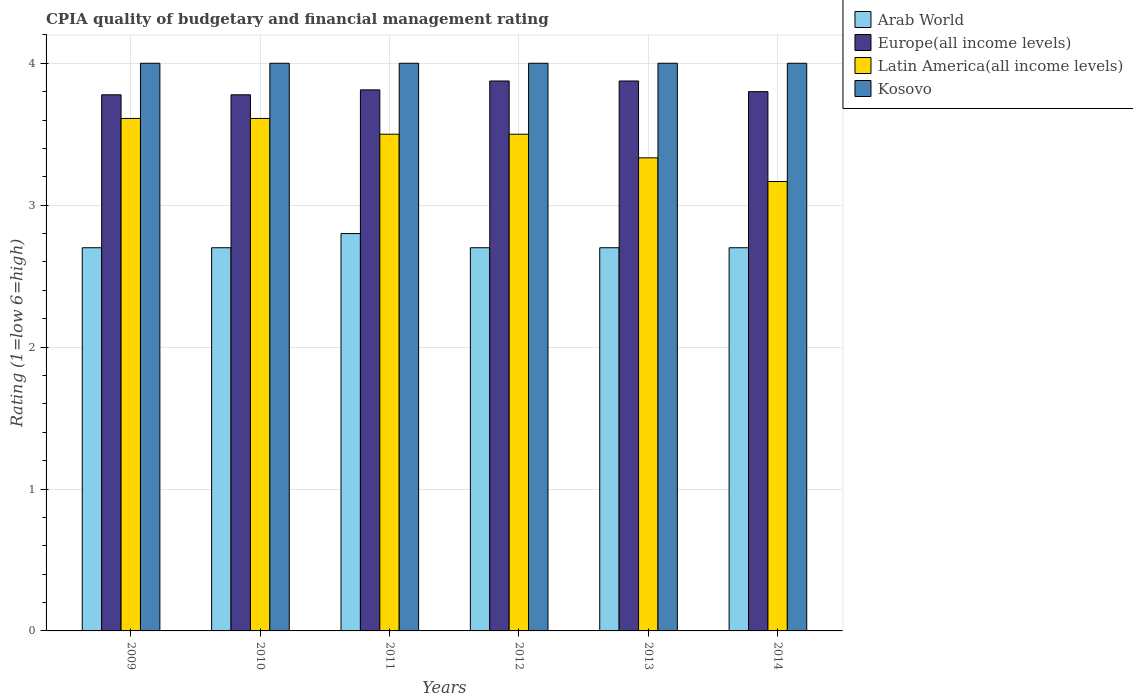Are the number of bars on each tick of the X-axis equal?
Make the answer very short. Yes. How many bars are there on the 1st tick from the left?
Make the answer very short. 4. What is the label of the 4th group of bars from the left?
Your response must be concise. 2012. In how many cases, is the number of bars for a given year not equal to the number of legend labels?
Your answer should be compact. 0. What is the CPIA rating in Europe(all income levels) in 2010?
Make the answer very short. 3.78. Across all years, what is the maximum CPIA rating in Latin America(all income levels)?
Your response must be concise. 3.61. Across all years, what is the minimum CPIA rating in Latin America(all income levels)?
Ensure brevity in your answer.  3.17. In which year was the CPIA rating in Kosovo maximum?
Offer a very short reply. 2009. What is the total CPIA rating in Latin America(all income levels) in the graph?
Give a very brief answer. 20.72. What is the difference between the CPIA rating in Latin America(all income levels) in 2009 and that in 2013?
Provide a short and direct response. 0.28. What is the difference between the CPIA rating in Latin America(all income levels) in 2014 and the CPIA rating in Europe(all income levels) in 2012?
Offer a very short reply. -0.71. What is the average CPIA rating in Latin America(all income levels) per year?
Offer a very short reply. 3.45. In the year 2013, what is the difference between the CPIA rating in Kosovo and CPIA rating in Arab World?
Offer a terse response. 1.3. In how many years, is the CPIA rating in Kosovo greater than 2.8?
Provide a succinct answer. 6. What is the ratio of the CPIA rating in Europe(all income levels) in 2009 to that in 2013?
Ensure brevity in your answer.  0.97. Is the CPIA rating in Latin America(all income levels) in 2010 less than that in 2012?
Provide a succinct answer. No. What is the difference between the highest and the second highest CPIA rating in Arab World?
Provide a short and direct response. 0.1. What is the difference between the highest and the lowest CPIA rating in Latin America(all income levels)?
Give a very brief answer. 0.44. Is it the case that in every year, the sum of the CPIA rating in Arab World and CPIA rating in Kosovo is greater than the sum of CPIA rating in Europe(all income levels) and CPIA rating in Latin America(all income levels)?
Make the answer very short. Yes. What does the 3rd bar from the left in 2012 represents?
Your answer should be very brief. Latin America(all income levels). What does the 4th bar from the right in 2012 represents?
Offer a terse response. Arab World. Is it the case that in every year, the sum of the CPIA rating in Europe(all income levels) and CPIA rating in Latin America(all income levels) is greater than the CPIA rating in Arab World?
Make the answer very short. Yes. How many bars are there?
Give a very brief answer. 24. Are all the bars in the graph horizontal?
Offer a very short reply. No. What is the difference between two consecutive major ticks on the Y-axis?
Offer a terse response. 1. Where does the legend appear in the graph?
Offer a very short reply. Top right. What is the title of the graph?
Ensure brevity in your answer.  CPIA quality of budgetary and financial management rating. Does "Finland" appear as one of the legend labels in the graph?
Provide a succinct answer. No. What is the label or title of the X-axis?
Give a very brief answer. Years. What is the label or title of the Y-axis?
Your answer should be compact. Rating (1=low 6=high). What is the Rating (1=low 6=high) in Arab World in 2009?
Provide a succinct answer. 2.7. What is the Rating (1=low 6=high) of Europe(all income levels) in 2009?
Keep it short and to the point. 3.78. What is the Rating (1=low 6=high) of Latin America(all income levels) in 2009?
Provide a short and direct response. 3.61. What is the Rating (1=low 6=high) of Europe(all income levels) in 2010?
Provide a short and direct response. 3.78. What is the Rating (1=low 6=high) in Latin America(all income levels) in 2010?
Ensure brevity in your answer.  3.61. What is the Rating (1=low 6=high) in Europe(all income levels) in 2011?
Provide a short and direct response. 3.81. What is the Rating (1=low 6=high) of Arab World in 2012?
Your response must be concise. 2.7. What is the Rating (1=low 6=high) in Europe(all income levels) in 2012?
Make the answer very short. 3.88. What is the Rating (1=low 6=high) in Latin America(all income levels) in 2012?
Your answer should be very brief. 3.5. What is the Rating (1=low 6=high) in Kosovo in 2012?
Offer a very short reply. 4. What is the Rating (1=low 6=high) in Europe(all income levels) in 2013?
Your answer should be compact. 3.88. What is the Rating (1=low 6=high) of Latin America(all income levels) in 2013?
Your response must be concise. 3.33. What is the Rating (1=low 6=high) in Kosovo in 2013?
Offer a very short reply. 4. What is the Rating (1=low 6=high) of Latin America(all income levels) in 2014?
Your answer should be very brief. 3.17. What is the Rating (1=low 6=high) in Kosovo in 2014?
Your answer should be very brief. 4. Across all years, what is the maximum Rating (1=low 6=high) in Europe(all income levels)?
Offer a terse response. 3.88. Across all years, what is the maximum Rating (1=low 6=high) in Latin America(all income levels)?
Provide a short and direct response. 3.61. Across all years, what is the minimum Rating (1=low 6=high) of Europe(all income levels)?
Offer a very short reply. 3.78. Across all years, what is the minimum Rating (1=low 6=high) in Latin America(all income levels)?
Give a very brief answer. 3.17. What is the total Rating (1=low 6=high) in Europe(all income levels) in the graph?
Give a very brief answer. 22.92. What is the total Rating (1=low 6=high) of Latin America(all income levels) in the graph?
Give a very brief answer. 20.72. What is the total Rating (1=low 6=high) of Kosovo in the graph?
Provide a short and direct response. 24. What is the difference between the Rating (1=low 6=high) of Kosovo in 2009 and that in 2010?
Offer a terse response. 0. What is the difference between the Rating (1=low 6=high) of Europe(all income levels) in 2009 and that in 2011?
Your answer should be very brief. -0.03. What is the difference between the Rating (1=low 6=high) of Europe(all income levels) in 2009 and that in 2012?
Offer a terse response. -0.1. What is the difference between the Rating (1=low 6=high) in Kosovo in 2009 and that in 2012?
Your answer should be very brief. 0. What is the difference between the Rating (1=low 6=high) of Arab World in 2009 and that in 2013?
Provide a succinct answer. 0. What is the difference between the Rating (1=low 6=high) in Europe(all income levels) in 2009 and that in 2013?
Offer a very short reply. -0.1. What is the difference between the Rating (1=low 6=high) of Latin America(all income levels) in 2009 and that in 2013?
Ensure brevity in your answer.  0.28. What is the difference between the Rating (1=low 6=high) in Arab World in 2009 and that in 2014?
Your answer should be compact. 0. What is the difference between the Rating (1=low 6=high) in Europe(all income levels) in 2009 and that in 2014?
Offer a terse response. -0.02. What is the difference between the Rating (1=low 6=high) in Latin America(all income levels) in 2009 and that in 2014?
Make the answer very short. 0.44. What is the difference between the Rating (1=low 6=high) in Arab World in 2010 and that in 2011?
Offer a very short reply. -0.1. What is the difference between the Rating (1=low 6=high) of Europe(all income levels) in 2010 and that in 2011?
Your response must be concise. -0.03. What is the difference between the Rating (1=low 6=high) in Latin America(all income levels) in 2010 and that in 2011?
Offer a very short reply. 0.11. What is the difference between the Rating (1=low 6=high) in Arab World in 2010 and that in 2012?
Your response must be concise. 0. What is the difference between the Rating (1=low 6=high) of Europe(all income levels) in 2010 and that in 2012?
Make the answer very short. -0.1. What is the difference between the Rating (1=low 6=high) in Latin America(all income levels) in 2010 and that in 2012?
Your answer should be very brief. 0.11. What is the difference between the Rating (1=low 6=high) of Europe(all income levels) in 2010 and that in 2013?
Your response must be concise. -0.1. What is the difference between the Rating (1=low 6=high) in Latin America(all income levels) in 2010 and that in 2013?
Your answer should be very brief. 0.28. What is the difference between the Rating (1=low 6=high) of Kosovo in 2010 and that in 2013?
Provide a succinct answer. 0. What is the difference between the Rating (1=low 6=high) of Arab World in 2010 and that in 2014?
Provide a short and direct response. 0. What is the difference between the Rating (1=low 6=high) in Europe(all income levels) in 2010 and that in 2014?
Provide a succinct answer. -0.02. What is the difference between the Rating (1=low 6=high) of Latin America(all income levels) in 2010 and that in 2014?
Offer a very short reply. 0.44. What is the difference between the Rating (1=low 6=high) in Arab World in 2011 and that in 2012?
Your answer should be compact. 0.1. What is the difference between the Rating (1=low 6=high) in Europe(all income levels) in 2011 and that in 2012?
Your response must be concise. -0.06. What is the difference between the Rating (1=low 6=high) in Latin America(all income levels) in 2011 and that in 2012?
Provide a short and direct response. 0. What is the difference between the Rating (1=low 6=high) of Arab World in 2011 and that in 2013?
Your response must be concise. 0.1. What is the difference between the Rating (1=low 6=high) of Europe(all income levels) in 2011 and that in 2013?
Offer a very short reply. -0.06. What is the difference between the Rating (1=low 6=high) in Kosovo in 2011 and that in 2013?
Ensure brevity in your answer.  0. What is the difference between the Rating (1=low 6=high) in Europe(all income levels) in 2011 and that in 2014?
Your response must be concise. 0.01. What is the difference between the Rating (1=low 6=high) in Arab World in 2012 and that in 2013?
Offer a terse response. 0. What is the difference between the Rating (1=low 6=high) of Europe(all income levels) in 2012 and that in 2013?
Your answer should be very brief. 0. What is the difference between the Rating (1=low 6=high) of Latin America(all income levels) in 2012 and that in 2013?
Your answer should be compact. 0.17. What is the difference between the Rating (1=low 6=high) in Kosovo in 2012 and that in 2013?
Ensure brevity in your answer.  0. What is the difference between the Rating (1=low 6=high) in Europe(all income levels) in 2012 and that in 2014?
Your answer should be very brief. 0.07. What is the difference between the Rating (1=low 6=high) of Europe(all income levels) in 2013 and that in 2014?
Your answer should be compact. 0.07. What is the difference between the Rating (1=low 6=high) of Latin America(all income levels) in 2013 and that in 2014?
Offer a very short reply. 0.17. What is the difference between the Rating (1=low 6=high) of Arab World in 2009 and the Rating (1=low 6=high) of Europe(all income levels) in 2010?
Offer a very short reply. -1.08. What is the difference between the Rating (1=low 6=high) in Arab World in 2009 and the Rating (1=low 6=high) in Latin America(all income levels) in 2010?
Give a very brief answer. -0.91. What is the difference between the Rating (1=low 6=high) of Arab World in 2009 and the Rating (1=low 6=high) of Kosovo in 2010?
Provide a succinct answer. -1.3. What is the difference between the Rating (1=low 6=high) of Europe(all income levels) in 2009 and the Rating (1=low 6=high) of Kosovo in 2010?
Offer a terse response. -0.22. What is the difference between the Rating (1=low 6=high) of Latin America(all income levels) in 2009 and the Rating (1=low 6=high) of Kosovo in 2010?
Offer a terse response. -0.39. What is the difference between the Rating (1=low 6=high) in Arab World in 2009 and the Rating (1=low 6=high) in Europe(all income levels) in 2011?
Provide a succinct answer. -1.11. What is the difference between the Rating (1=low 6=high) of Arab World in 2009 and the Rating (1=low 6=high) of Latin America(all income levels) in 2011?
Keep it short and to the point. -0.8. What is the difference between the Rating (1=low 6=high) in Arab World in 2009 and the Rating (1=low 6=high) in Kosovo in 2011?
Your response must be concise. -1.3. What is the difference between the Rating (1=low 6=high) of Europe(all income levels) in 2009 and the Rating (1=low 6=high) of Latin America(all income levels) in 2011?
Offer a terse response. 0.28. What is the difference between the Rating (1=low 6=high) in Europe(all income levels) in 2009 and the Rating (1=low 6=high) in Kosovo in 2011?
Provide a succinct answer. -0.22. What is the difference between the Rating (1=low 6=high) in Latin America(all income levels) in 2009 and the Rating (1=low 6=high) in Kosovo in 2011?
Your answer should be compact. -0.39. What is the difference between the Rating (1=low 6=high) in Arab World in 2009 and the Rating (1=low 6=high) in Europe(all income levels) in 2012?
Offer a very short reply. -1.18. What is the difference between the Rating (1=low 6=high) of Arab World in 2009 and the Rating (1=low 6=high) of Latin America(all income levels) in 2012?
Your response must be concise. -0.8. What is the difference between the Rating (1=low 6=high) of Arab World in 2009 and the Rating (1=low 6=high) of Kosovo in 2012?
Make the answer very short. -1.3. What is the difference between the Rating (1=low 6=high) in Europe(all income levels) in 2009 and the Rating (1=low 6=high) in Latin America(all income levels) in 2012?
Your answer should be compact. 0.28. What is the difference between the Rating (1=low 6=high) of Europe(all income levels) in 2009 and the Rating (1=low 6=high) of Kosovo in 2012?
Offer a terse response. -0.22. What is the difference between the Rating (1=low 6=high) of Latin America(all income levels) in 2009 and the Rating (1=low 6=high) of Kosovo in 2012?
Provide a short and direct response. -0.39. What is the difference between the Rating (1=low 6=high) of Arab World in 2009 and the Rating (1=low 6=high) of Europe(all income levels) in 2013?
Provide a short and direct response. -1.18. What is the difference between the Rating (1=low 6=high) in Arab World in 2009 and the Rating (1=low 6=high) in Latin America(all income levels) in 2013?
Offer a terse response. -0.63. What is the difference between the Rating (1=low 6=high) in Europe(all income levels) in 2009 and the Rating (1=low 6=high) in Latin America(all income levels) in 2013?
Provide a succinct answer. 0.44. What is the difference between the Rating (1=low 6=high) in Europe(all income levels) in 2009 and the Rating (1=low 6=high) in Kosovo in 2013?
Your answer should be compact. -0.22. What is the difference between the Rating (1=low 6=high) of Latin America(all income levels) in 2009 and the Rating (1=low 6=high) of Kosovo in 2013?
Offer a terse response. -0.39. What is the difference between the Rating (1=low 6=high) of Arab World in 2009 and the Rating (1=low 6=high) of Latin America(all income levels) in 2014?
Your response must be concise. -0.47. What is the difference between the Rating (1=low 6=high) of Arab World in 2009 and the Rating (1=low 6=high) of Kosovo in 2014?
Provide a succinct answer. -1.3. What is the difference between the Rating (1=low 6=high) in Europe(all income levels) in 2009 and the Rating (1=low 6=high) in Latin America(all income levels) in 2014?
Your response must be concise. 0.61. What is the difference between the Rating (1=low 6=high) in Europe(all income levels) in 2009 and the Rating (1=low 6=high) in Kosovo in 2014?
Keep it short and to the point. -0.22. What is the difference between the Rating (1=low 6=high) in Latin America(all income levels) in 2009 and the Rating (1=low 6=high) in Kosovo in 2014?
Give a very brief answer. -0.39. What is the difference between the Rating (1=low 6=high) in Arab World in 2010 and the Rating (1=low 6=high) in Europe(all income levels) in 2011?
Your answer should be very brief. -1.11. What is the difference between the Rating (1=low 6=high) in Europe(all income levels) in 2010 and the Rating (1=low 6=high) in Latin America(all income levels) in 2011?
Your response must be concise. 0.28. What is the difference between the Rating (1=low 6=high) of Europe(all income levels) in 2010 and the Rating (1=low 6=high) of Kosovo in 2011?
Ensure brevity in your answer.  -0.22. What is the difference between the Rating (1=low 6=high) in Latin America(all income levels) in 2010 and the Rating (1=low 6=high) in Kosovo in 2011?
Provide a succinct answer. -0.39. What is the difference between the Rating (1=low 6=high) of Arab World in 2010 and the Rating (1=low 6=high) of Europe(all income levels) in 2012?
Provide a succinct answer. -1.18. What is the difference between the Rating (1=low 6=high) in Arab World in 2010 and the Rating (1=low 6=high) in Latin America(all income levels) in 2012?
Offer a terse response. -0.8. What is the difference between the Rating (1=low 6=high) in Arab World in 2010 and the Rating (1=low 6=high) in Kosovo in 2012?
Offer a very short reply. -1.3. What is the difference between the Rating (1=low 6=high) in Europe(all income levels) in 2010 and the Rating (1=low 6=high) in Latin America(all income levels) in 2012?
Your response must be concise. 0.28. What is the difference between the Rating (1=low 6=high) of Europe(all income levels) in 2010 and the Rating (1=low 6=high) of Kosovo in 2012?
Your answer should be very brief. -0.22. What is the difference between the Rating (1=low 6=high) of Latin America(all income levels) in 2010 and the Rating (1=low 6=high) of Kosovo in 2012?
Provide a succinct answer. -0.39. What is the difference between the Rating (1=low 6=high) in Arab World in 2010 and the Rating (1=low 6=high) in Europe(all income levels) in 2013?
Ensure brevity in your answer.  -1.18. What is the difference between the Rating (1=low 6=high) of Arab World in 2010 and the Rating (1=low 6=high) of Latin America(all income levels) in 2013?
Keep it short and to the point. -0.63. What is the difference between the Rating (1=low 6=high) of Europe(all income levels) in 2010 and the Rating (1=low 6=high) of Latin America(all income levels) in 2013?
Your response must be concise. 0.44. What is the difference between the Rating (1=low 6=high) in Europe(all income levels) in 2010 and the Rating (1=low 6=high) in Kosovo in 2013?
Give a very brief answer. -0.22. What is the difference between the Rating (1=low 6=high) of Latin America(all income levels) in 2010 and the Rating (1=low 6=high) of Kosovo in 2013?
Give a very brief answer. -0.39. What is the difference between the Rating (1=low 6=high) in Arab World in 2010 and the Rating (1=low 6=high) in Europe(all income levels) in 2014?
Keep it short and to the point. -1.1. What is the difference between the Rating (1=low 6=high) of Arab World in 2010 and the Rating (1=low 6=high) of Latin America(all income levels) in 2014?
Offer a terse response. -0.47. What is the difference between the Rating (1=low 6=high) of Europe(all income levels) in 2010 and the Rating (1=low 6=high) of Latin America(all income levels) in 2014?
Offer a very short reply. 0.61. What is the difference between the Rating (1=low 6=high) of Europe(all income levels) in 2010 and the Rating (1=low 6=high) of Kosovo in 2014?
Keep it short and to the point. -0.22. What is the difference between the Rating (1=low 6=high) in Latin America(all income levels) in 2010 and the Rating (1=low 6=high) in Kosovo in 2014?
Offer a very short reply. -0.39. What is the difference between the Rating (1=low 6=high) of Arab World in 2011 and the Rating (1=low 6=high) of Europe(all income levels) in 2012?
Give a very brief answer. -1.07. What is the difference between the Rating (1=low 6=high) of Arab World in 2011 and the Rating (1=low 6=high) of Latin America(all income levels) in 2012?
Ensure brevity in your answer.  -0.7. What is the difference between the Rating (1=low 6=high) in Arab World in 2011 and the Rating (1=low 6=high) in Kosovo in 2012?
Ensure brevity in your answer.  -1.2. What is the difference between the Rating (1=low 6=high) of Europe(all income levels) in 2011 and the Rating (1=low 6=high) of Latin America(all income levels) in 2012?
Give a very brief answer. 0.31. What is the difference between the Rating (1=low 6=high) in Europe(all income levels) in 2011 and the Rating (1=low 6=high) in Kosovo in 2012?
Make the answer very short. -0.19. What is the difference between the Rating (1=low 6=high) in Arab World in 2011 and the Rating (1=low 6=high) in Europe(all income levels) in 2013?
Give a very brief answer. -1.07. What is the difference between the Rating (1=low 6=high) in Arab World in 2011 and the Rating (1=low 6=high) in Latin America(all income levels) in 2013?
Your answer should be very brief. -0.53. What is the difference between the Rating (1=low 6=high) in Arab World in 2011 and the Rating (1=low 6=high) in Kosovo in 2013?
Your answer should be very brief. -1.2. What is the difference between the Rating (1=low 6=high) of Europe(all income levels) in 2011 and the Rating (1=low 6=high) of Latin America(all income levels) in 2013?
Offer a very short reply. 0.48. What is the difference between the Rating (1=low 6=high) in Europe(all income levels) in 2011 and the Rating (1=low 6=high) in Kosovo in 2013?
Offer a terse response. -0.19. What is the difference between the Rating (1=low 6=high) in Latin America(all income levels) in 2011 and the Rating (1=low 6=high) in Kosovo in 2013?
Offer a terse response. -0.5. What is the difference between the Rating (1=low 6=high) of Arab World in 2011 and the Rating (1=low 6=high) of Latin America(all income levels) in 2014?
Offer a terse response. -0.37. What is the difference between the Rating (1=low 6=high) of Europe(all income levels) in 2011 and the Rating (1=low 6=high) of Latin America(all income levels) in 2014?
Offer a terse response. 0.65. What is the difference between the Rating (1=low 6=high) in Europe(all income levels) in 2011 and the Rating (1=low 6=high) in Kosovo in 2014?
Offer a terse response. -0.19. What is the difference between the Rating (1=low 6=high) of Arab World in 2012 and the Rating (1=low 6=high) of Europe(all income levels) in 2013?
Offer a very short reply. -1.18. What is the difference between the Rating (1=low 6=high) in Arab World in 2012 and the Rating (1=low 6=high) in Latin America(all income levels) in 2013?
Your answer should be compact. -0.63. What is the difference between the Rating (1=low 6=high) in Europe(all income levels) in 2012 and the Rating (1=low 6=high) in Latin America(all income levels) in 2013?
Provide a succinct answer. 0.54. What is the difference between the Rating (1=low 6=high) in Europe(all income levels) in 2012 and the Rating (1=low 6=high) in Kosovo in 2013?
Provide a short and direct response. -0.12. What is the difference between the Rating (1=low 6=high) in Arab World in 2012 and the Rating (1=low 6=high) in Latin America(all income levels) in 2014?
Your response must be concise. -0.47. What is the difference between the Rating (1=low 6=high) in Europe(all income levels) in 2012 and the Rating (1=low 6=high) in Latin America(all income levels) in 2014?
Offer a very short reply. 0.71. What is the difference between the Rating (1=low 6=high) of Europe(all income levels) in 2012 and the Rating (1=low 6=high) of Kosovo in 2014?
Keep it short and to the point. -0.12. What is the difference between the Rating (1=low 6=high) of Latin America(all income levels) in 2012 and the Rating (1=low 6=high) of Kosovo in 2014?
Keep it short and to the point. -0.5. What is the difference between the Rating (1=low 6=high) in Arab World in 2013 and the Rating (1=low 6=high) in Europe(all income levels) in 2014?
Keep it short and to the point. -1.1. What is the difference between the Rating (1=low 6=high) in Arab World in 2013 and the Rating (1=low 6=high) in Latin America(all income levels) in 2014?
Ensure brevity in your answer.  -0.47. What is the difference between the Rating (1=low 6=high) of Europe(all income levels) in 2013 and the Rating (1=low 6=high) of Latin America(all income levels) in 2014?
Your response must be concise. 0.71. What is the difference between the Rating (1=low 6=high) of Europe(all income levels) in 2013 and the Rating (1=low 6=high) of Kosovo in 2014?
Your response must be concise. -0.12. What is the average Rating (1=low 6=high) of Arab World per year?
Make the answer very short. 2.72. What is the average Rating (1=low 6=high) in Europe(all income levels) per year?
Provide a short and direct response. 3.82. What is the average Rating (1=low 6=high) in Latin America(all income levels) per year?
Your answer should be compact. 3.45. In the year 2009, what is the difference between the Rating (1=low 6=high) of Arab World and Rating (1=low 6=high) of Europe(all income levels)?
Keep it short and to the point. -1.08. In the year 2009, what is the difference between the Rating (1=low 6=high) of Arab World and Rating (1=low 6=high) of Latin America(all income levels)?
Your answer should be very brief. -0.91. In the year 2009, what is the difference between the Rating (1=low 6=high) of Europe(all income levels) and Rating (1=low 6=high) of Kosovo?
Keep it short and to the point. -0.22. In the year 2009, what is the difference between the Rating (1=low 6=high) of Latin America(all income levels) and Rating (1=low 6=high) of Kosovo?
Your response must be concise. -0.39. In the year 2010, what is the difference between the Rating (1=low 6=high) of Arab World and Rating (1=low 6=high) of Europe(all income levels)?
Your answer should be very brief. -1.08. In the year 2010, what is the difference between the Rating (1=low 6=high) in Arab World and Rating (1=low 6=high) in Latin America(all income levels)?
Give a very brief answer. -0.91. In the year 2010, what is the difference between the Rating (1=low 6=high) of Europe(all income levels) and Rating (1=low 6=high) of Kosovo?
Make the answer very short. -0.22. In the year 2010, what is the difference between the Rating (1=low 6=high) of Latin America(all income levels) and Rating (1=low 6=high) of Kosovo?
Your answer should be compact. -0.39. In the year 2011, what is the difference between the Rating (1=low 6=high) of Arab World and Rating (1=low 6=high) of Europe(all income levels)?
Provide a succinct answer. -1.01. In the year 2011, what is the difference between the Rating (1=low 6=high) in Arab World and Rating (1=low 6=high) in Latin America(all income levels)?
Offer a terse response. -0.7. In the year 2011, what is the difference between the Rating (1=low 6=high) of Europe(all income levels) and Rating (1=low 6=high) of Latin America(all income levels)?
Provide a short and direct response. 0.31. In the year 2011, what is the difference between the Rating (1=low 6=high) of Europe(all income levels) and Rating (1=low 6=high) of Kosovo?
Ensure brevity in your answer.  -0.19. In the year 2012, what is the difference between the Rating (1=low 6=high) of Arab World and Rating (1=low 6=high) of Europe(all income levels)?
Your answer should be compact. -1.18. In the year 2012, what is the difference between the Rating (1=low 6=high) in Arab World and Rating (1=low 6=high) in Latin America(all income levels)?
Keep it short and to the point. -0.8. In the year 2012, what is the difference between the Rating (1=low 6=high) in Europe(all income levels) and Rating (1=low 6=high) in Latin America(all income levels)?
Your answer should be very brief. 0.38. In the year 2012, what is the difference between the Rating (1=low 6=high) in Europe(all income levels) and Rating (1=low 6=high) in Kosovo?
Your response must be concise. -0.12. In the year 2012, what is the difference between the Rating (1=low 6=high) in Latin America(all income levels) and Rating (1=low 6=high) in Kosovo?
Keep it short and to the point. -0.5. In the year 2013, what is the difference between the Rating (1=low 6=high) of Arab World and Rating (1=low 6=high) of Europe(all income levels)?
Ensure brevity in your answer.  -1.18. In the year 2013, what is the difference between the Rating (1=low 6=high) in Arab World and Rating (1=low 6=high) in Latin America(all income levels)?
Make the answer very short. -0.63. In the year 2013, what is the difference between the Rating (1=low 6=high) in Europe(all income levels) and Rating (1=low 6=high) in Latin America(all income levels)?
Your answer should be very brief. 0.54. In the year 2013, what is the difference between the Rating (1=low 6=high) in Europe(all income levels) and Rating (1=low 6=high) in Kosovo?
Your answer should be very brief. -0.12. In the year 2013, what is the difference between the Rating (1=low 6=high) of Latin America(all income levels) and Rating (1=low 6=high) of Kosovo?
Make the answer very short. -0.67. In the year 2014, what is the difference between the Rating (1=low 6=high) in Arab World and Rating (1=low 6=high) in Latin America(all income levels)?
Provide a short and direct response. -0.47. In the year 2014, what is the difference between the Rating (1=low 6=high) of Europe(all income levels) and Rating (1=low 6=high) of Latin America(all income levels)?
Provide a short and direct response. 0.63. In the year 2014, what is the difference between the Rating (1=low 6=high) in Europe(all income levels) and Rating (1=low 6=high) in Kosovo?
Offer a very short reply. -0.2. What is the ratio of the Rating (1=low 6=high) in Arab World in 2009 to that in 2010?
Offer a very short reply. 1. What is the ratio of the Rating (1=low 6=high) in Europe(all income levels) in 2009 to that in 2010?
Make the answer very short. 1. What is the ratio of the Rating (1=low 6=high) in Arab World in 2009 to that in 2011?
Offer a terse response. 0.96. What is the ratio of the Rating (1=low 6=high) in Europe(all income levels) in 2009 to that in 2011?
Keep it short and to the point. 0.99. What is the ratio of the Rating (1=low 6=high) in Latin America(all income levels) in 2009 to that in 2011?
Your answer should be compact. 1.03. What is the ratio of the Rating (1=low 6=high) in Kosovo in 2009 to that in 2011?
Provide a succinct answer. 1. What is the ratio of the Rating (1=low 6=high) of Europe(all income levels) in 2009 to that in 2012?
Provide a succinct answer. 0.97. What is the ratio of the Rating (1=low 6=high) in Latin America(all income levels) in 2009 to that in 2012?
Give a very brief answer. 1.03. What is the ratio of the Rating (1=low 6=high) in Kosovo in 2009 to that in 2012?
Keep it short and to the point. 1. What is the ratio of the Rating (1=low 6=high) in Europe(all income levels) in 2009 to that in 2013?
Make the answer very short. 0.97. What is the ratio of the Rating (1=low 6=high) of Latin America(all income levels) in 2009 to that in 2013?
Provide a succinct answer. 1.08. What is the ratio of the Rating (1=low 6=high) of Kosovo in 2009 to that in 2013?
Your answer should be compact. 1. What is the ratio of the Rating (1=low 6=high) of Arab World in 2009 to that in 2014?
Give a very brief answer. 1. What is the ratio of the Rating (1=low 6=high) in Latin America(all income levels) in 2009 to that in 2014?
Your answer should be very brief. 1.14. What is the ratio of the Rating (1=low 6=high) of Kosovo in 2009 to that in 2014?
Make the answer very short. 1. What is the ratio of the Rating (1=low 6=high) in Europe(all income levels) in 2010 to that in 2011?
Keep it short and to the point. 0.99. What is the ratio of the Rating (1=low 6=high) of Latin America(all income levels) in 2010 to that in 2011?
Provide a short and direct response. 1.03. What is the ratio of the Rating (1=low 6=high) of Europe(all income levels) in 2010 to that in 2012?
Ensure brevity in your answer.  0.97. What is the ratio of the Rating (1=low 6=high) in Latin America(all income levels) in 2010 to that in 2012?
Offer a very short reply. 1.03. What is the ratio of the Rating (1=low 6=high) in Europe(all income levels) in 2010 to that in 2013?
Keep it short and to the point. 0.97. What is the ratio of the Rating (1=low 6=high) of Kosovo in 2010 to that in 2013?
Ensure brevity in your answer.  1. What is the ratio of the Rating (1=low 6=high) of Arab World in 2010 to that in 2014?
Your answer should be very brief. 1. What is the ratio of the Rating (1=low 6=high) of Latin America(all income levels) in 2010 to that in 2014?
Your answer should be compact. 1.14. What is the ratio of the Rating (1=low 6=high) of Kosovo in 2010 to that in 2014?
Ensure brevity in your answer.  1. What is the ratio of the Rating (1=low 6=high) in Arab World in 2011 to that in 2012?
Your response must be concise. 1.04. What is the ratio of the Rating (1=low 6=high) in Europe(all income levels) in 2011 to that in 2012?
Provide a short and direct response. 0.98. What is the ratio of the Rating (1=low 6=high) of Arab World in 2011 to that in 2013?
Offer a very short reply. 1.04. What is the ratio of the Rating (1=low 6=high) of Europe(all income levels) in 2011 to that in 2013?
Your answer should be compact. 0.98. What is the ratio of the Rating (1=low 6=high) of Latin America(all income levels) in 2011 to that in 2013?
Keep it short and to the point. 1.05. What is the ratio of the Rating (1=low 6=high) of Kosovo in 2011 to that in 2013?
Keep it short and to the point. 1. What is the ratio of the Rating (1=low 6=high) of Arab World in 2011 to that in 2014?
Provide a succinct answer. 1.04. What is the ratio of the Rating (1=low 6=high) in Europe(all income levels) in 2011 to that in 2014?
Your answer should be very brief. 1. What is the ratio of the Rating (1=low 6=high) of Latin America(all income levels) in 2011 to that in 2014?
Your answer should be compact. 1.11. What is the ratio of the Rating (1=low 6=high) in Kosovo in 2011 to that in 2014?
Your answer should be compact. 1. What is the ratio of the Rating (1=low 6=high) in Europe(all income levels) in 2012 to that in 2013?
Give a very brief answer. 1. What is the ratio of the Rating (1=low 6=high) in Latin America(all income levels) in 2012 to that in 2013?
Provide a succinct answer. 1.05. What is the ratio of the Rating (1=low 6=high) of Arab World in 2012 to that in 2014?
Offer a terse response. 1. What is the ratio of the Rating (1=low 6=high) in Europe(all income levels) in 2012 to that in 2014?
Your answer should be compact. 1.02. What is the ratio of the Rating (1=low 6=high) of Latin America(all income levels) in 2012 to that in 2014?
Offer a very short reply. 1.11. What is the ratio of the Rating (1=low 6=high) of Europe(all income levels) in 2013 to that in 2014?
Your answer should be compact. 1.02. What is the ratio of the Rating (1=low 6=high) of Latin America(all income levels) in 2013 to that in 2014?
Your response must be concise. 1.05. What is the ratio of the Rating (1=low 6=high) of Kosovo in 2013 to that in 2014?
Keep it short and to the point. 1. What is the difference between the highest and the second highest Rating (1=low 6=high) of Arab World?
Offer a terse response. 0.1. What is the difference between the highest and the second highest Rating (1=low 6=high) of Latin America(all income levels)?
Keep it short and to the point. 0. What is the difference between the highest and the second highest Rating (1=low 6=high) of Kosovo?
Your response must be concise. 0. What is the difference between the highest and the lowest Rating (1=low 6=high) of Europe(all income levels)?
Offer a terse response. 0.1. What is the difference between the highest and the lowest Rating (1=low 6=high) of Latin America(all income levels)?
Provide a succinct answer. 0.44. 